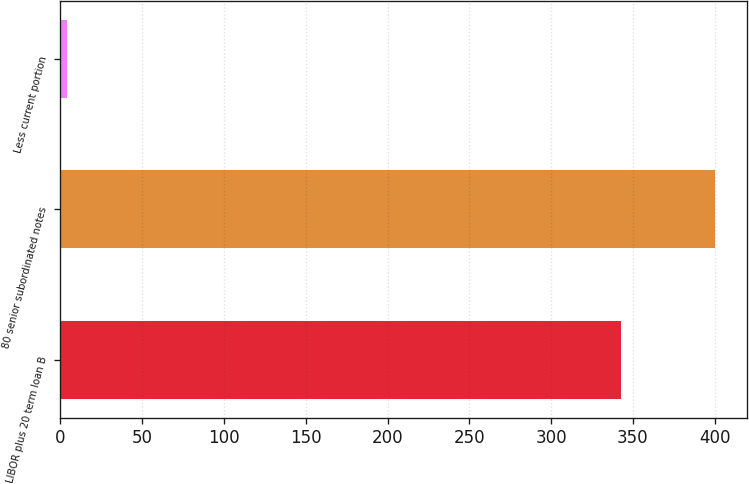<chart> <loc_0><loc_0><loc_500><loc_500><bar_chart><fcel>LIBOR plus 20 term loan B<fcel>80 senior subordinated notes<fcel>Less current portion<nl><fcel>343<fcel>400<fcel>4<nl></chart> 